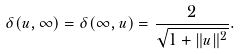Convert formula to latex. <formula><loc_0><loc_0><loc_500><loc_500>\delta ( u , \infty ) = \delta ( \infty , u ) = { \frac { 2 } { \sqrt { 1 + \| u \| ^ { 2 } } } } .</formula> 